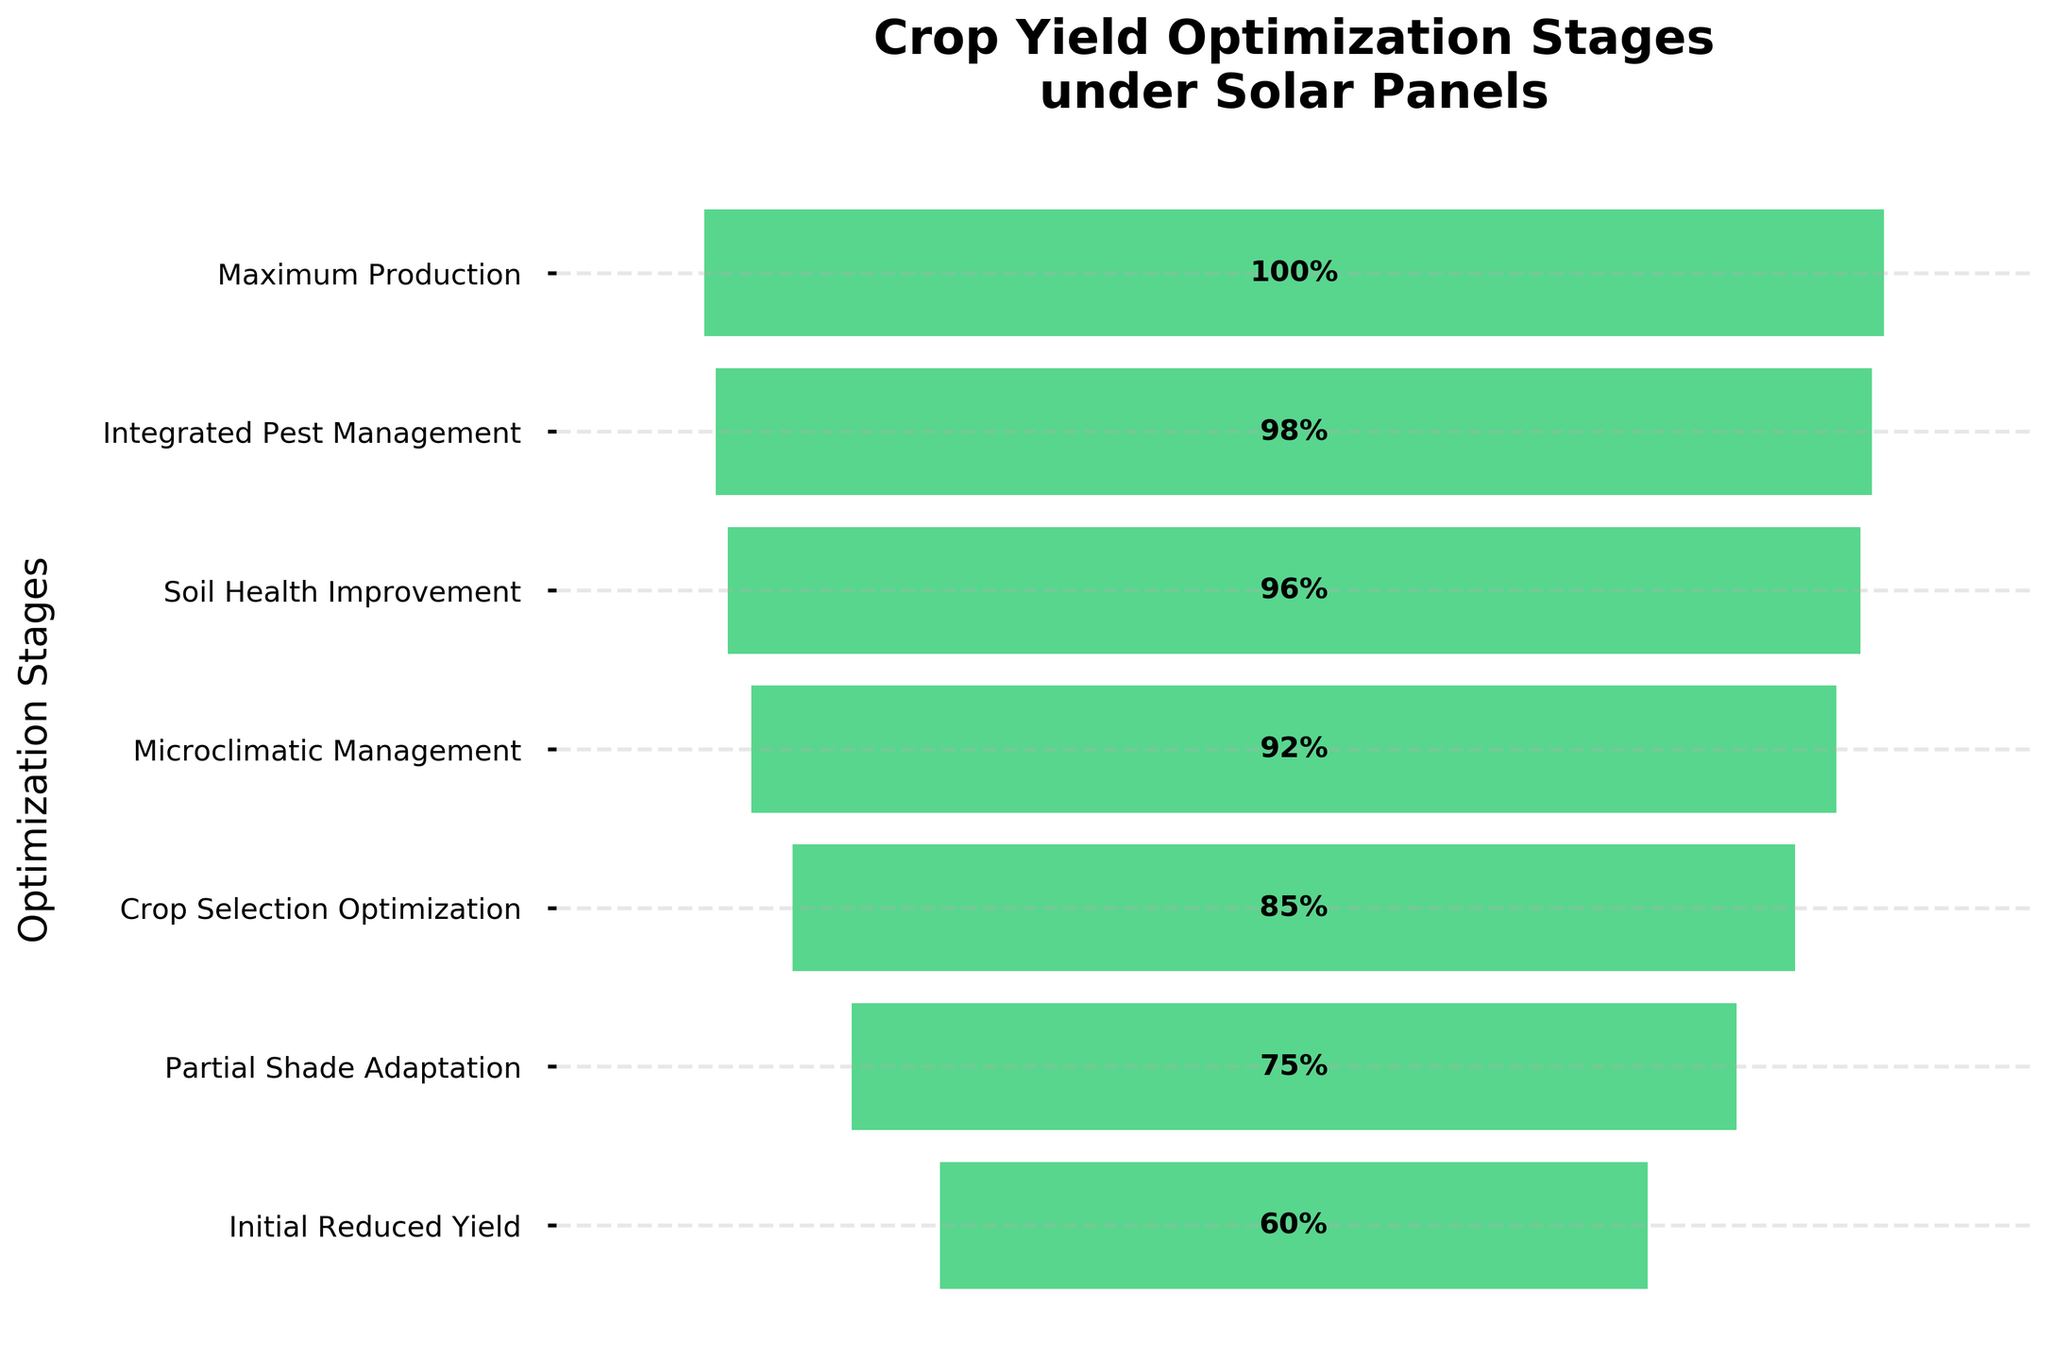What is the title of the chart? The chart title is placed at the top and reads "Crop Yield Optimization Stages under Solar Panels".
Answer: Crop Yield Optimization Stages under Solar Panels How many optimization stages are shown on the chart? Count the number of distinct stages listed on the Y-axis.
Answer: 7 Which stage has the lowest yield percentage? Identify the stage with the smallest value from the percentage labels within the bars.
Answer: Initial Reduced Yield What is the increase in yield percentage from "Partial Shade Adaptation" to "Soil Health Improvement"? Subtract the yield percentage of "Partial Shade Adaptation" from the yield percentage of "Soil Health Improvement": 96% - 75% = 21%.
Answer: 21% Which stage results in a yield percentage closest to 90%? Compare the yield percentages of all stages and identify the one closest to 90%.
Answer: Microclimatic Management (92%) Is the yield percentage in "Integrated Pest Management" greater than or less than in "Crop Selection Optimization"? Compare the yield percentages of "Integrated Pest Management" (98%) and "Crop Selection Optimization" (85%).
Answer: Greater What is the yield percentage difference between "Initial Reduced Yield" and "Maximum Production"? Subtract the yield percentage of "Initial Reduced Yield" from "Maximum Production": 100% - 60% = 40%.
Answer: 40% What is the average yield percentage across all stages? Sum all yield percentages and divide by the number of stages: (60% + 75% + 85% + 92% + 96% + 98% + 100%) / 7.
Answer: 86.57% Which optimization stage follows after "Crop Selection Optimization"? Identify the stage that is directly listed after "Crop Selection Optimization" on the Y-axis.
Answer: Microclimatic Management How much does the yield percentage increase in total from the initial reduced yield to maximum production? Calculate the increase by subtracting the initial yield percentage from the maximum: 100% - 60% = 40%.
Answer: 40% 